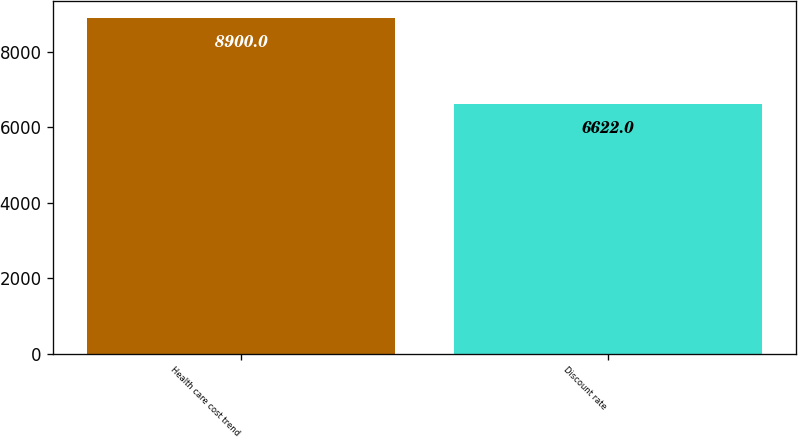<chart> <loc_0><loc_0><loc_500><loc_500><bar_chart><fcel>Health care cost trend<fcel>Discount rate<nl><fcel>8900<fcel>6622<nl></chart> 